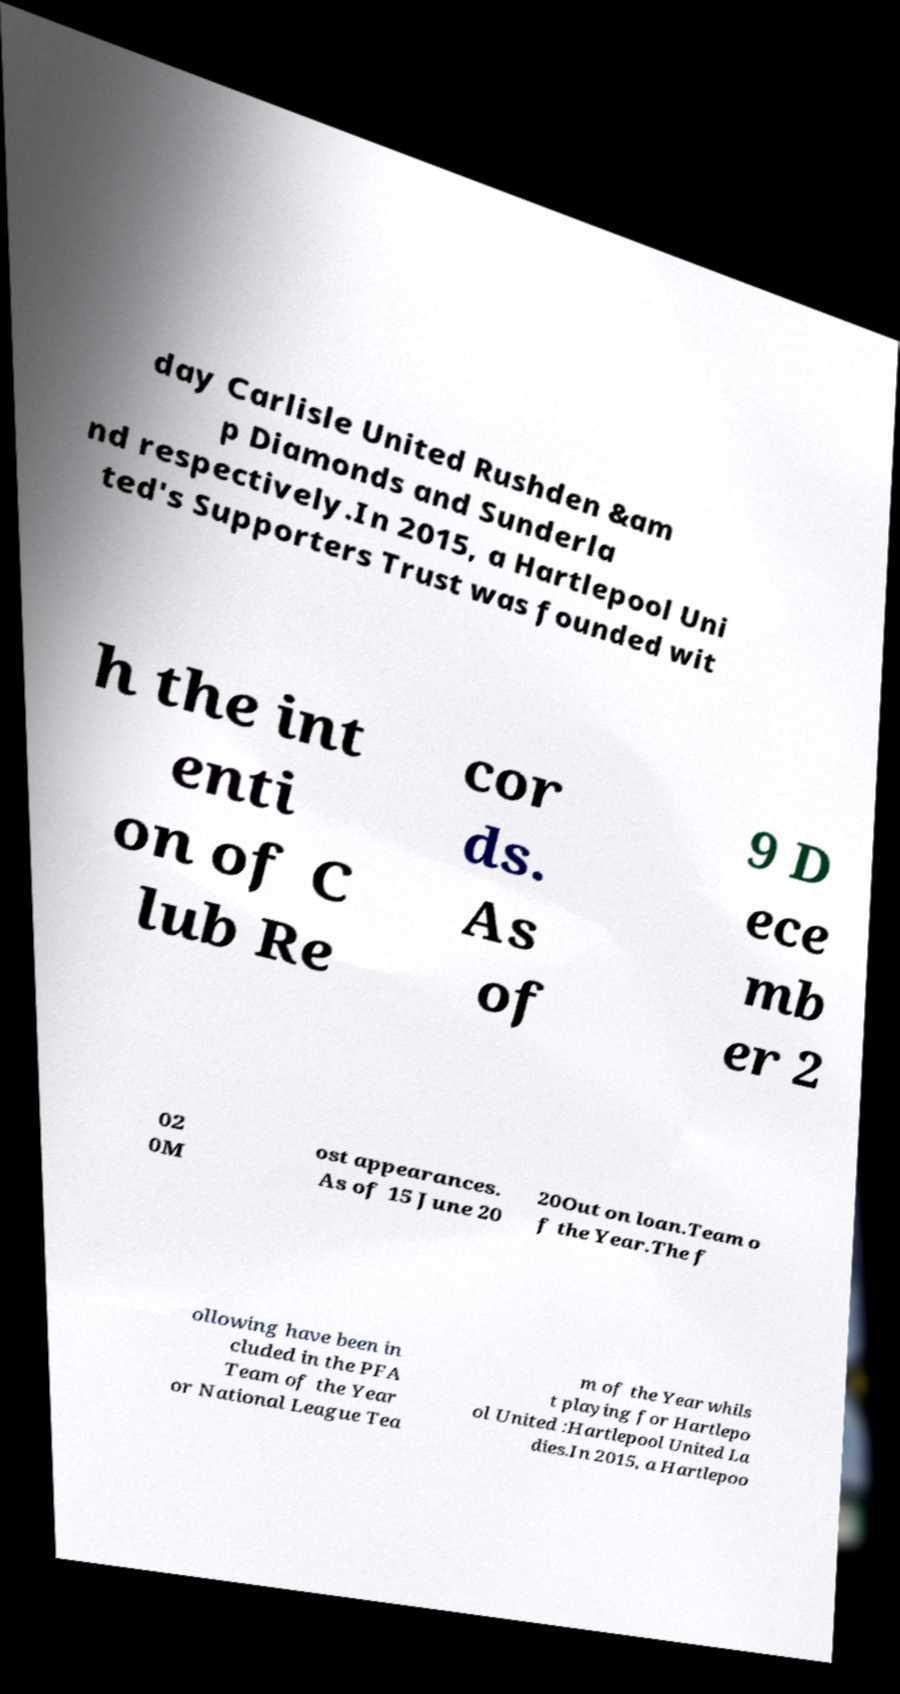Could you assist in decoding the text presented in this image and type it out clearly? day Carlisle United Rushden &am p Diamonds and Sunderla nd respectively.In 2015, a Hartlepool Uni ted's Supporters Trust was founded wit h the int enti on of C lub Re cor ds. As of 9 D ece mb er 2 02 0M ost appearances. As of 15 June 20 20Out on loan.Team o f the Year.The f ollowing have been in cluded in the PFA Team of the Year or National League Tea m of the Year whils t playing for Hartlepo ol United :Hartlepool United La dies.In 2015, a Hartlepoo 